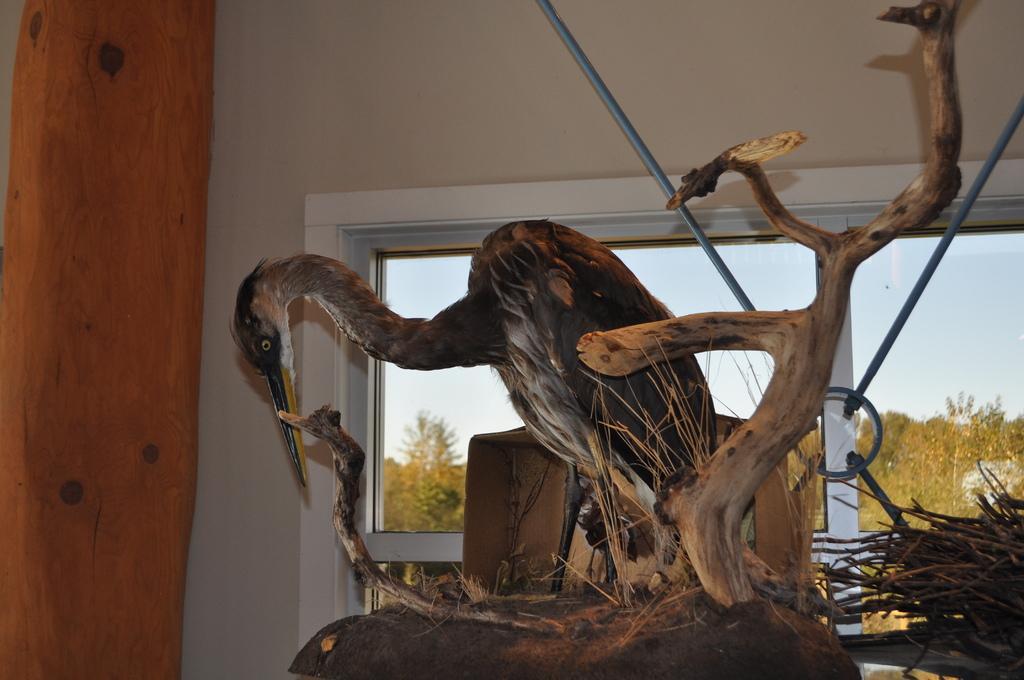Could you give a brief overview of what you see in this image? In this image I can see a bird, tree trunk and wood sticks. In the background I can see a wall, window, trees and the sky. This image is taken may be in a room. 